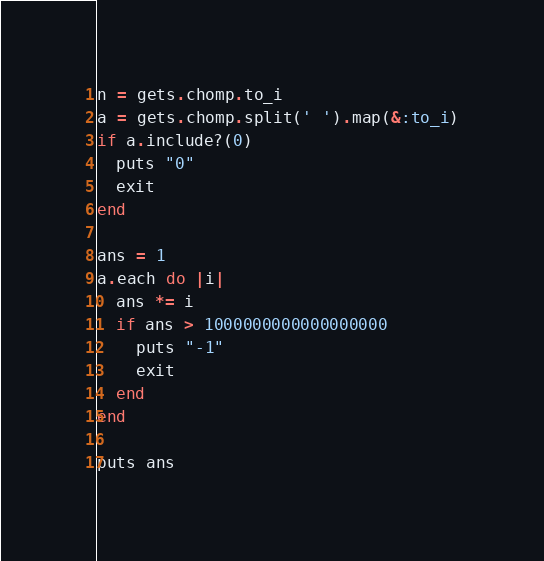Convert code to text. <code><loc_0><loc_0><loc_500><loc_500><_Ruby_>n = gets.chomp.to_i
a = gets.chomp.split(' ').map(&:to_i)
if a.include?(0)
  puts "0"
  exit
end

ans = 1
a.each do |i|
  ans *= i
  if ans > 1000000000000000000
    puts "-1"
    exit
  end
end

puts ans
</code> 